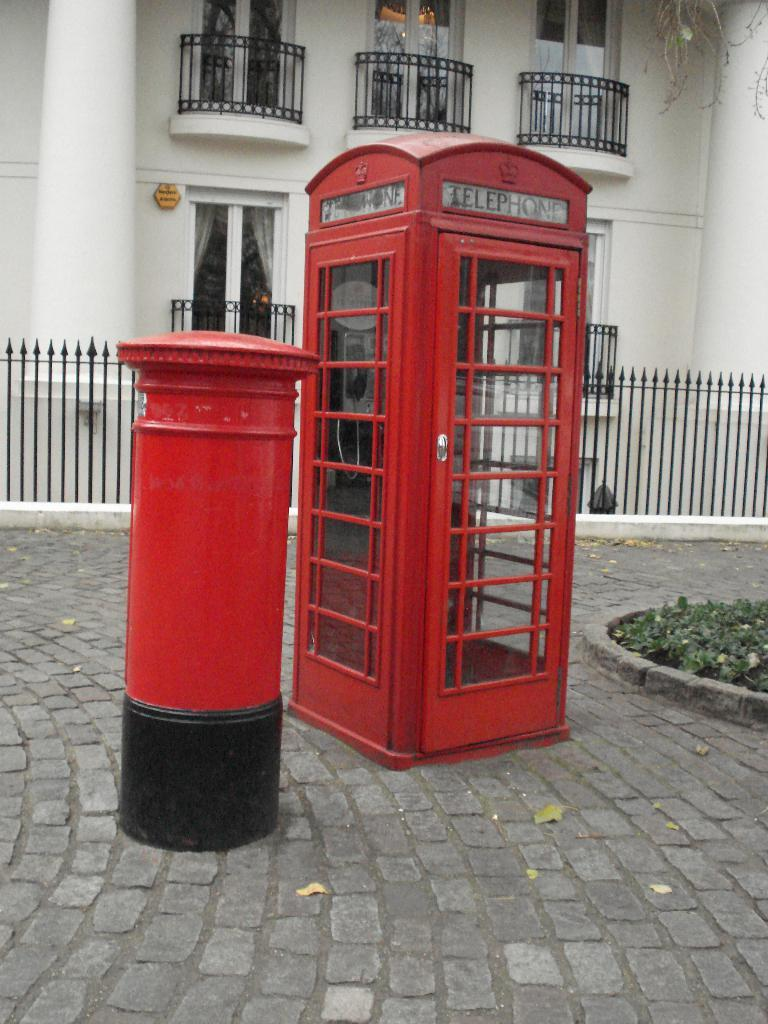<image>
Render a clear and concise summary of the photo. An old fashioned, red phone booth, with the word telephone printed at the top is in front of a building with several black balconies. 